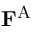<formula> <loc_0><loc_0><loc_500><loc_500>F ^ { A }</formula> 